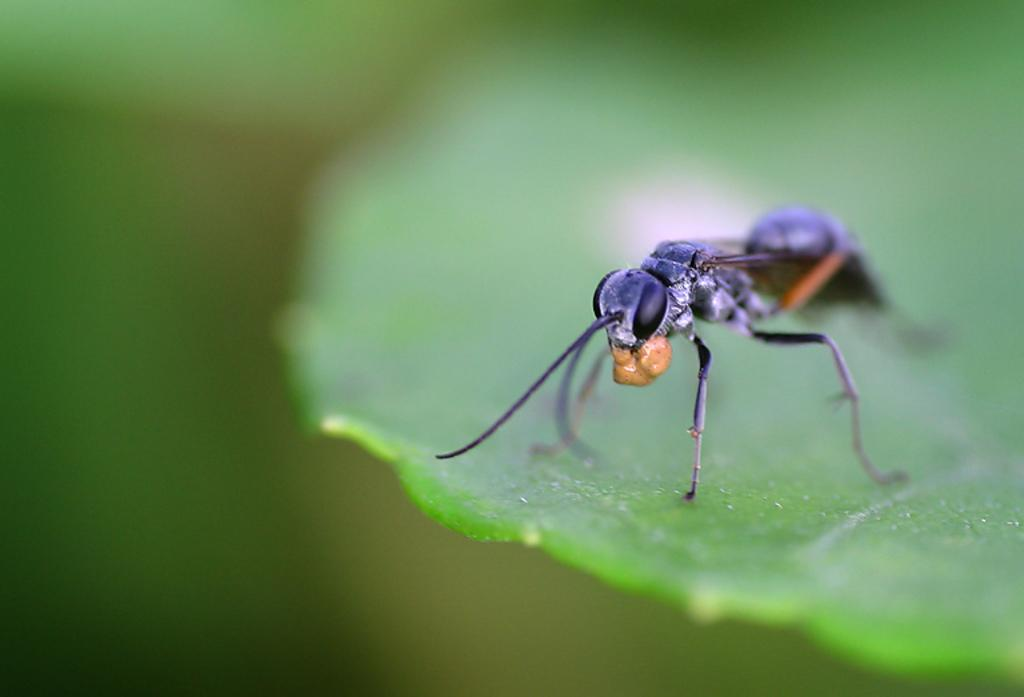What is present in the image? There is an insect in the image. Where is the insect located? The insect is on a leaf. What route does the insect take to reach the drink in the image? There is no drink present in the image, so the insect does not need to take a route to reach it. 